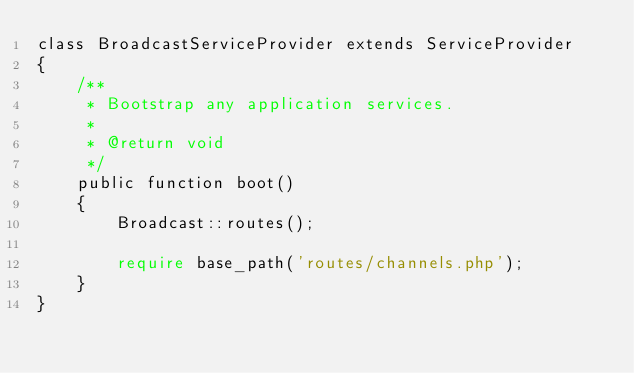<code> <loc_0><loc_0><loc_500><loc_500><_PHP_>class BroadcastServiceProvider extends ServiceProvider
{
    /**
     * Bootstrap any application services.
     *
     * @return void
     */
    public function boot()
    {
        Broadcast::routes();

        require base_path('routes/channels.php');
    }
}
</code> 